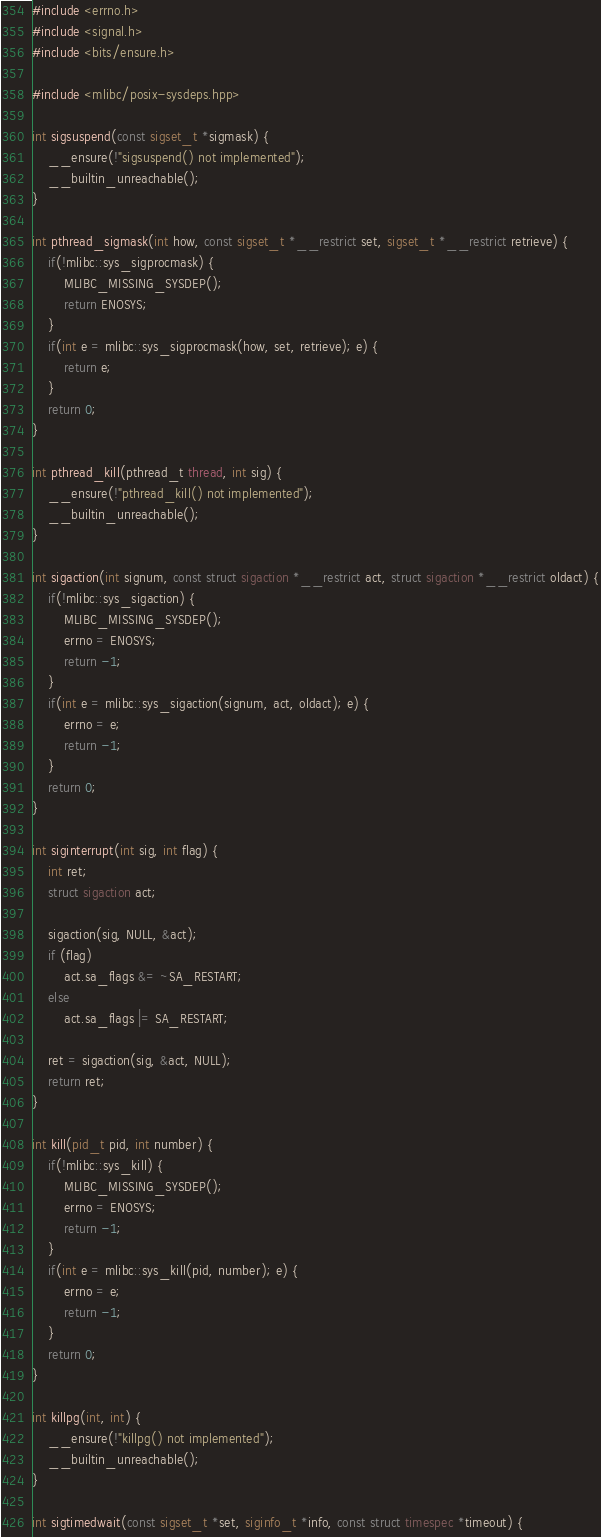Convert code to text. <code><loc_0><loc_0><loc_500><loc_500><_C++_>
#include <errno.h>
#include <signal.h>
#include <bits/ensure.h>

#include <mlibc/posix-sysdeps.hpp>

int sigsuspend(const sigset_t *sigmask) {
	__ensure(!"sigsuspend() not implemented");
	__builtin_unreachable();
}

int pthread_sigmask(int how, const sigset_t *__restrict set, sigset_t *__restrict retrieve) {
	if(!mlibc::sys_sigprocmask) {
		MLIBC_MISSING_SYSDEP();
		return ENOSYS;
	}
	if(int e = mlibc::sys_sigprocmask(how, set, retrieve); e) {
		return e;
	}
	return 0;
}

int pthread_kill(pthread_t thread, int sig) {
	__ensure(!"pthread_kill() not implemented");
	__builtin_unreachable();
}

int sigaction(int signum, const struct sigaction *__restrict act, struct sigaction *__restrict oldact) {
	if(!mlibc::sys_sigaction) {
		MLIBC_MISSING_SYSDEP();
		errno = ENOSYS;
		return -1;
	}
	if(int e = mlibc::sys_sigaction(signum, act, oldact); e) {
		errno = e;
		return -1;
	}
	return 0;
}

int siginterrupt(int sig, int flag) {
    int ret;
    struct sigaction act;

    sigaction(sig, NULL, &act);
    if (flag)
        act.sa_flags &= ~SA_RESTART;
    else
        act.sa_flags |= SA_RESTART;

    ret = sigaction(sig, &act, NULL);
    return ret;
}

int kill(pid_t pid, int number) {
	if(!mlibc::sys_kill) {
		MLIBC_MISSING_SYSDEP();
		errno = ENOSYS;
		return -1;
	}
	if(int e = mlibc::sys_kill(pid, number); e) {
		errno = e;
		return -1;
	}
	return 0;
}

int killpg(int, int) {
	__ensure(!"killpg() not implemented");
	__builtin_unreachable();
}

int sigtimedwait(const sigset_t *set, siginfo_t *info, const struct timespec *timeout) {</code> 